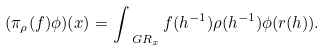Convert formula to latex. <formula><loc_0><loc_0><loc_500><loc_500>( \pi _ { \rho } ( f ) \phi ) ( x ) = \int _ { \ G R _ { x } } f ( h ^ { - 1 } ) \rho ( h ^ { - 1 } ) \phi ( r ( h ) ) .</formula> 